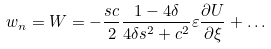<formula> <loc_0><loc_0><loc_500><loc_500>w _ { n } = W = - \frac { s c } { 2 } \frac { 1 - 4 \delta } { 4 \delta s ^ { 2 } + c ^ { 2 } } \varepsilon \frac { \partial U } { \partial \xi } + \dots</formula> 